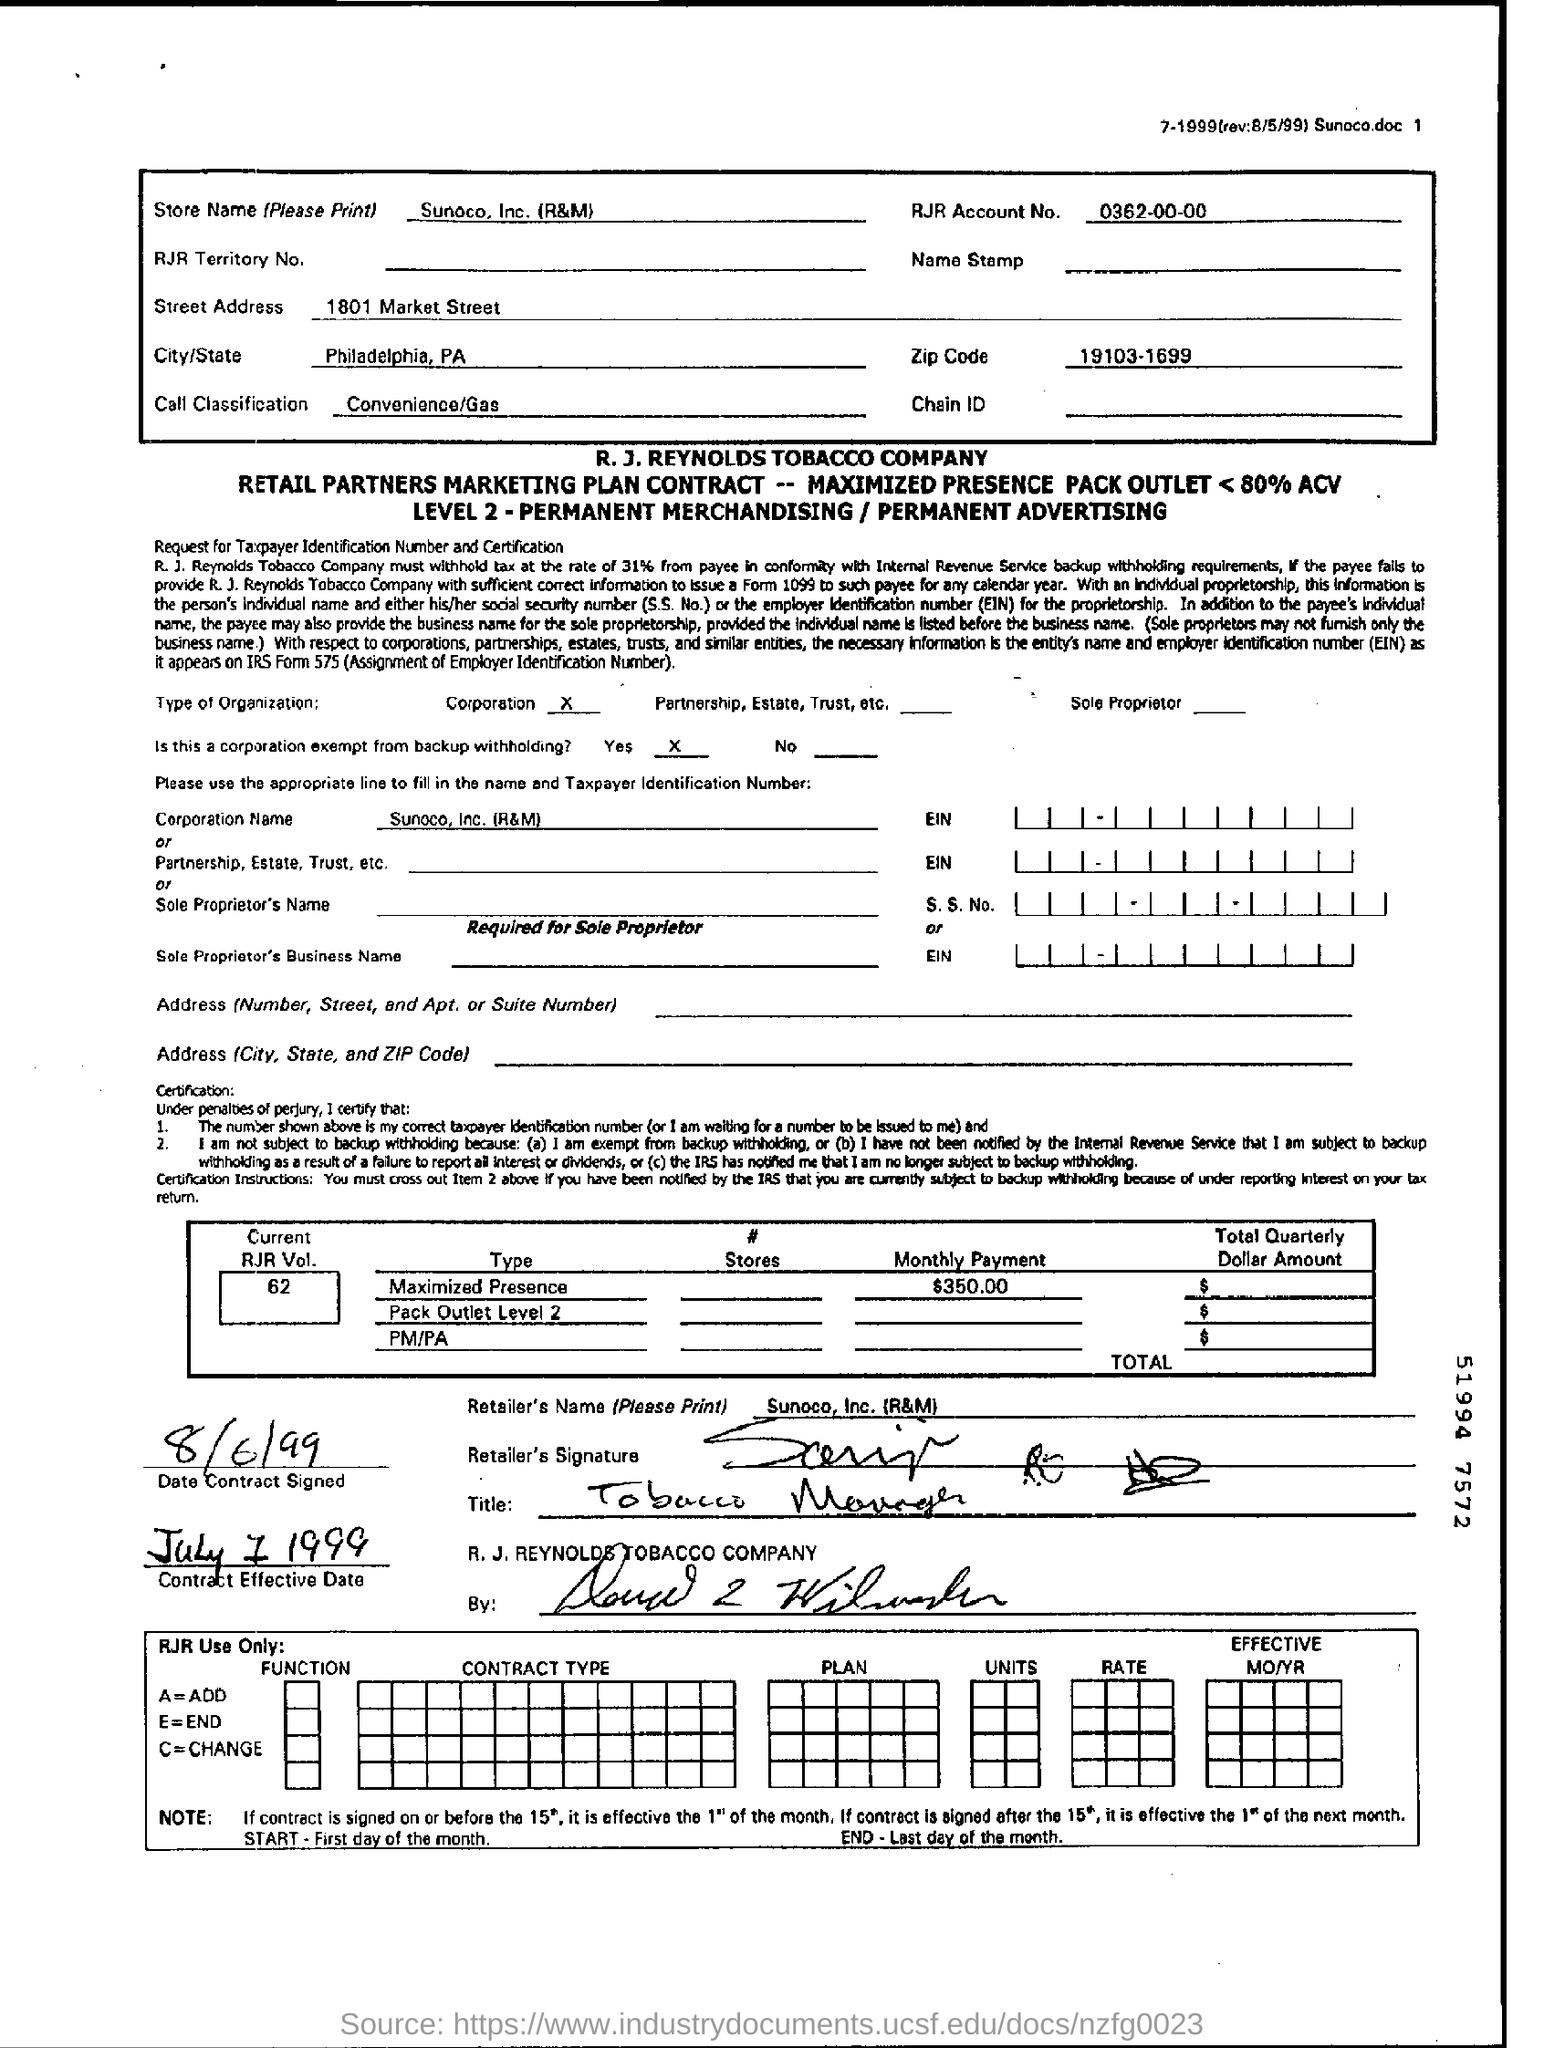Give some essential details in this illustration. The city mentioned in the box is Philadelphia, Pennsylvania. The zip code is "19103-1699. The contract was signed on August 6th, 1999. 